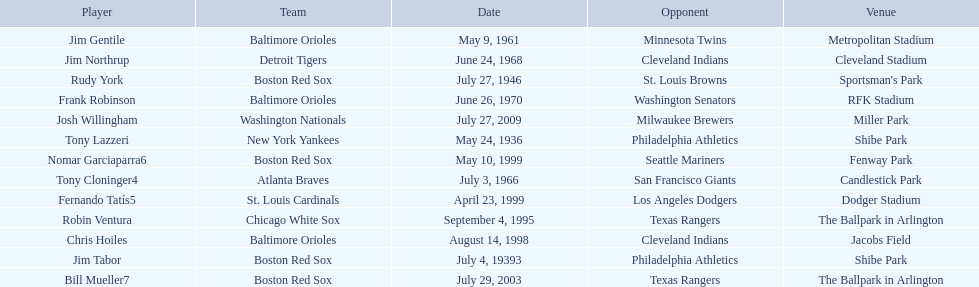What are the names of all the players? Tony Lazzeri, Jim Tabor, Rudy York, Jim Gentile, Tony Cloninger4, Jim Northrup, Frank Robinson, Robin Ventura, Chris Hoiles, Fernando Tatís5, Nomar Garciaparra6, Bill Mueller7, Josh Willingham. What are the names of all the teams holding home run records? New York Yankees, Boston Red Sox, Baltimore Orioles, Atlanta Braves, Detroit Tigers, Chicago White Sox, St. Louis Cardinals, Washington Nationals. Which player played for the new york yankees? Tony Lazzeri. 